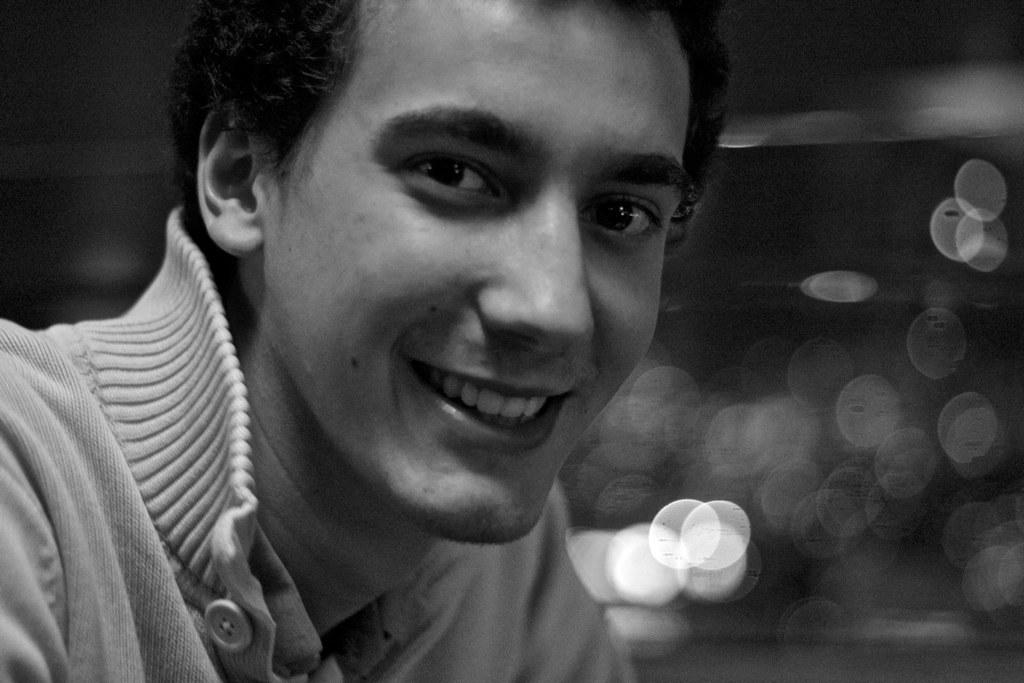What is the main subject of the image? There is a person in the image. Can you describe the background of the image? The background of the image is blurred. What type of cake can be smelled in the image? There is no cake present in the image, and therefore no scent can be detected. How many wheels are visible in the image? There are no wheels visible in the image. 